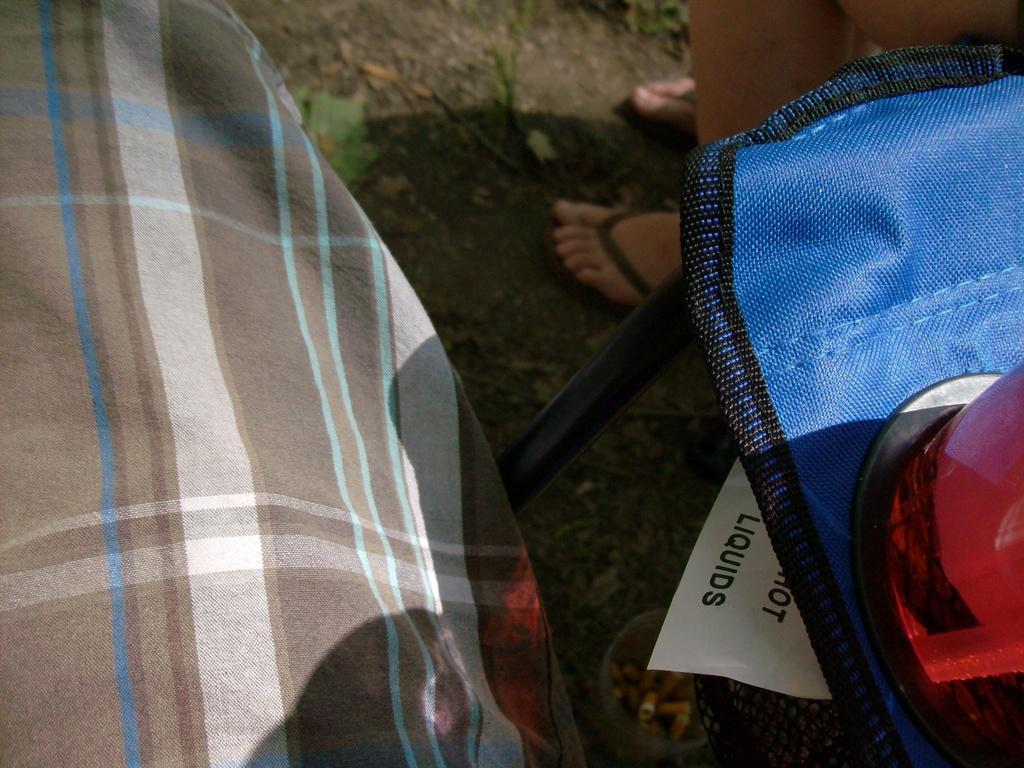Could you give a brief overview of what you see in this image? The picture consists of persons leg, vehicle, light, box. At the top there are soil, grass and plant. It is sunny. 